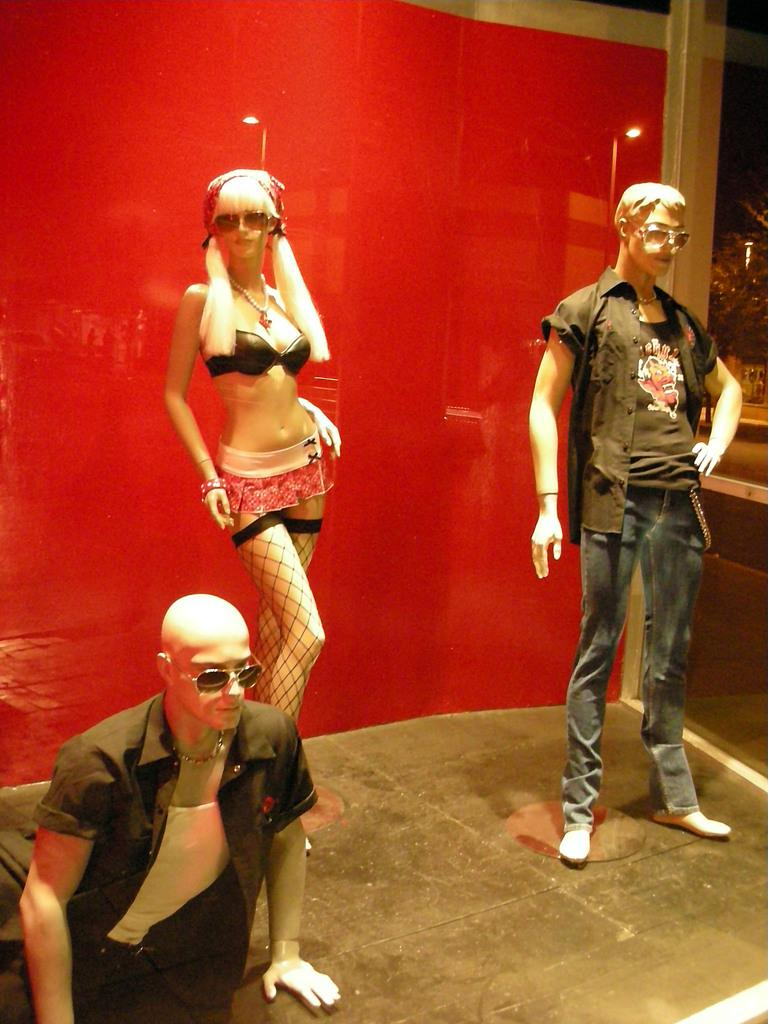How many mannequins are present in the image? There are three mannequins in the image. Can you describe the background of the image? There is a red sheet in the background of the image. What type of thrill can be experienced by the mannequins in the image? The mannequins in the image are not capable of experiencing thrill, as they are inanimate objects. 